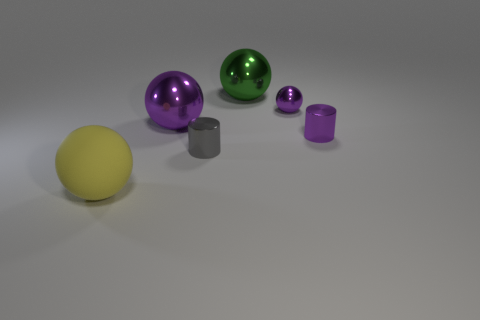Can you tell me the colors of the spheres and which one is the largest? Certainly! There are two spheres in the image. The largest sphere is green, and there is a smaller purple sphere as well. 